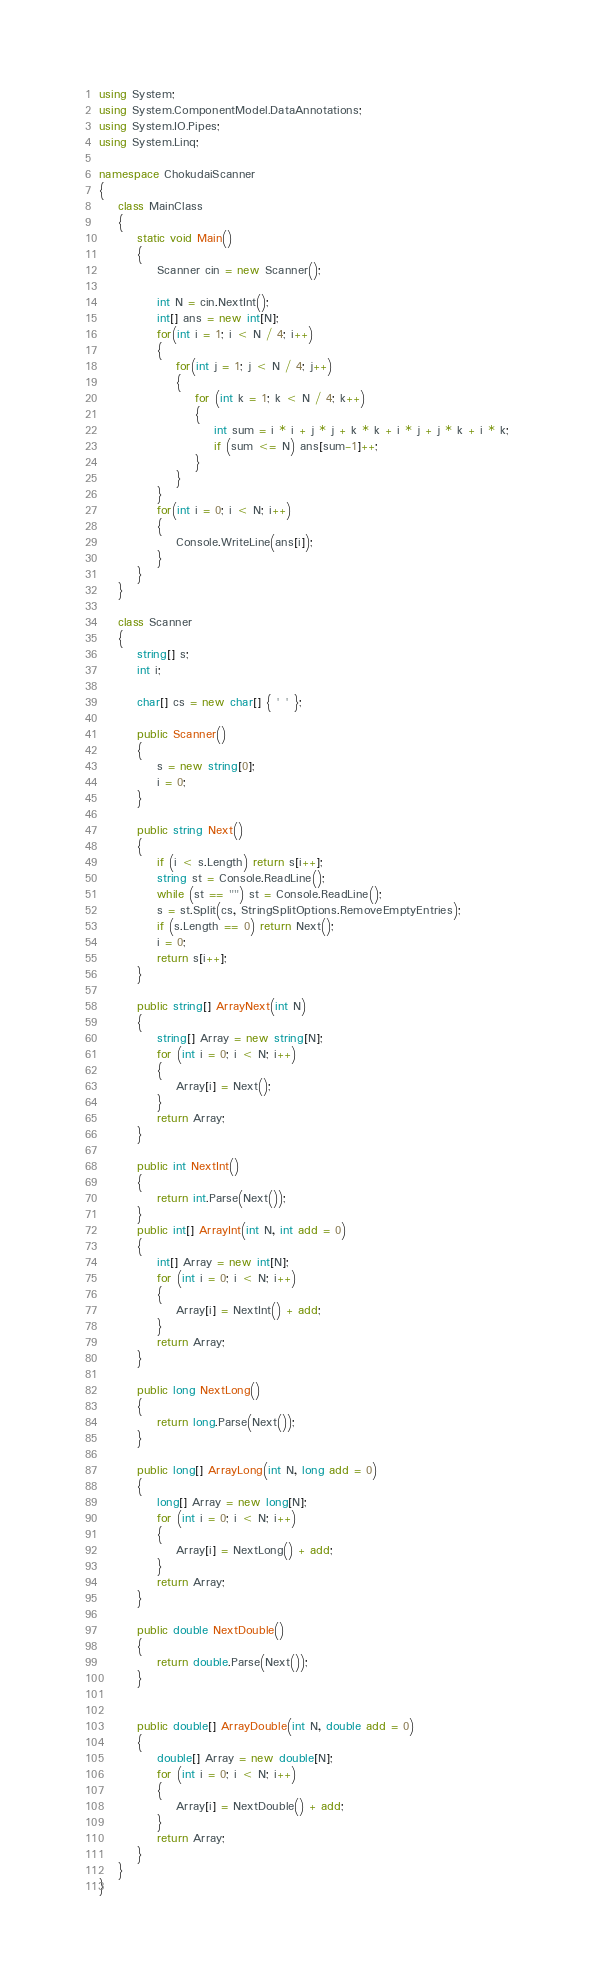Convert code to text. <code><loc_0><loc_0><loc_500><loc_500><_C#_>using System;
using System.ComponentModel.DataAnnotations;
using System.IO.Pipes;
using System.Linq;

namespace ChokudaiScanner
{
    class MainClass
    {
        static void Main()
        {
            Scanner cin = new Scanner();

            int N = cin.NextInt();
            int[] ans = new int[N];
            for(int i = 1; i < N / 4; i++)
            {
                for(int j = 1; j < N / 4; j++)
                {
                    for (int k = 1; k < N / 4; k++)
                    {
                        int sum = i * i + j * j + k * k + i * j + j * k + i * k;
                        if (sum <= N) ans[sum-1]++;
                    }
                }
            }
            for(int i = 0; i < N; i++)
            {
                Console.WriteLine(ans[i]);
            }
        }
    }

    class Scanner
    {
        string[] s;
        int i;

        char[] cs = new char[] { ' ' };

        public Scanner()
        {
            s = new string[0];
            i = 0;
        }

        public string Next()
        {
            if (i < s.Length) return s[i++];
            string st = Console.ReadLine();
            while (st == "") st = Console.ReadLine();
            s = st.Split(cs, StringSplitOptions.RemoveEmptyEntries);
            if (s.Length == 0) return Next();
            i = 0;
            return s[i++];
        }

        public string[] ArrayNext(int N)
        {
            string[] Array = new string[N];
            for (int i = 0; i < N; i++)
            {
                Array[i] = Next();
            }
            return Array;
        }

        public int NextInt()
        {
            return int.Parse(Next());
        }
        public int[] ArrayInt(int N, int add = 0)
        {
            int[] Array = new int[N];
            for (int i = 0; i < N; i++)
            {
                Array[i] = NextInt() + add;
            }
            return Array;
        }

        public long NextLong()
        {
            return long.Parse(Next());
        }

        public long[] ArrayLong(int N, long add = 0)
        {
            long[] Array = new long[N];
            for (int i = 0; i < N; i++)
            {
                Array[i] = NextLong() + add;
            }
            return Array;
        }

        public double NextDouble()
        {
            return double.Parse(Next());
        }


        public double[] ArrayDouble(int N, double add = 0)
        {
            double[] Array = new double[N];
            for (int i = 0; i < N; i++)
            {
                Array[i] = NextDouble() + add;
            }
            return Array;
        }
    }
}

</code> 